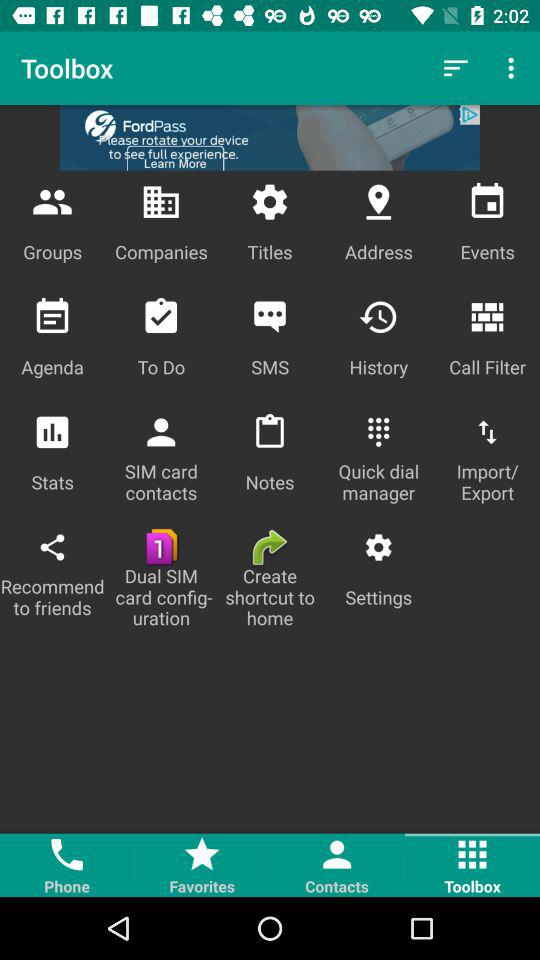Which tab is selected? The selected tab is "Toolbox". 